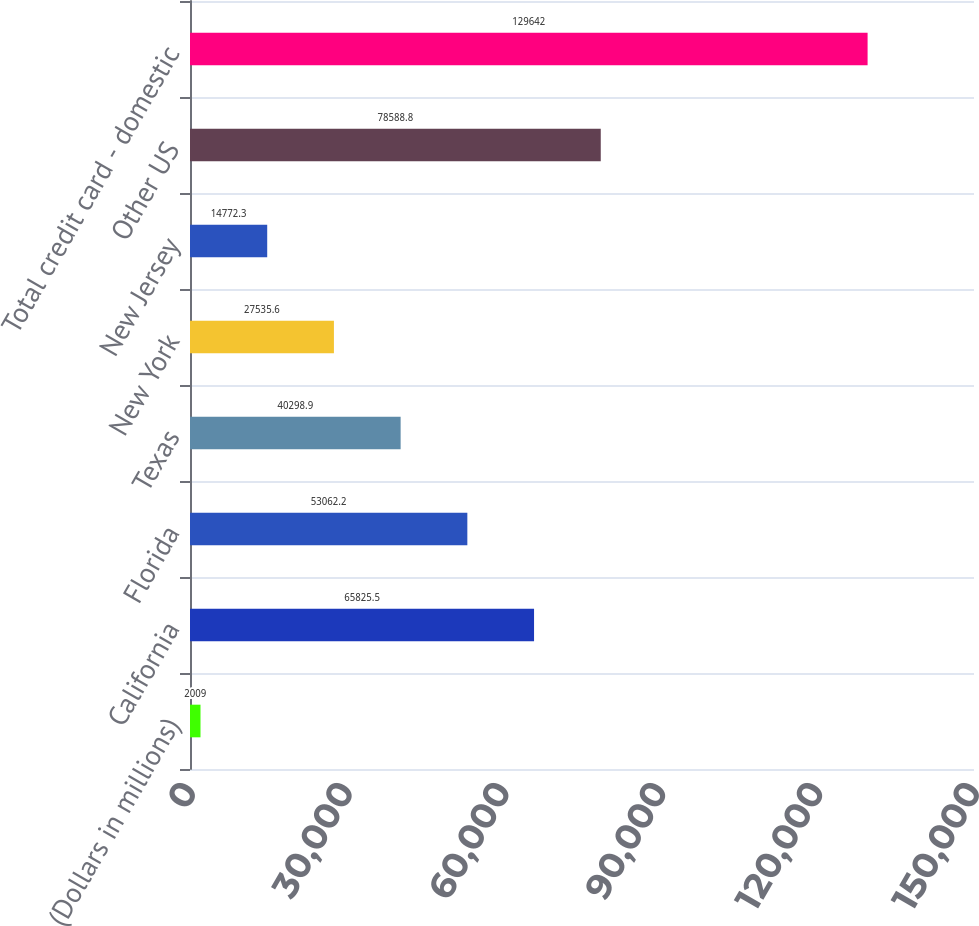<chart> <loc_0><loc_0><loc_500><loc_500><bar_chart><fcel>(Dollars in millions)<fcel>California<fcel>Florida<fcel>Texas<fcel>New York<fcel>New Jersey<fcel>Other US<fcel>Total credit card - domestic<nl><fcel>2009<fcel>65825.5<fcel>53062.2<fcel>40298.9<fcel>27535.6<fcel>14772.3<fcel>78588.8<fcel>129642<nl></chart> 